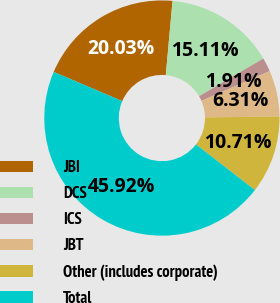Convert chart. <chart><loc_0><loc_0><loc_500><loc_500><pie_chart><fcel>JBI<fcel>DCS<fcel>ICS<fcel>JBT<fcel>Other (includes corporate)<fcel>Total<nl><fcel>20.03%<fcel>15.11%<fcel>1.91%<fcel>6.31%<fcel>10.71%<fcel>45.92%<nl></chart> 